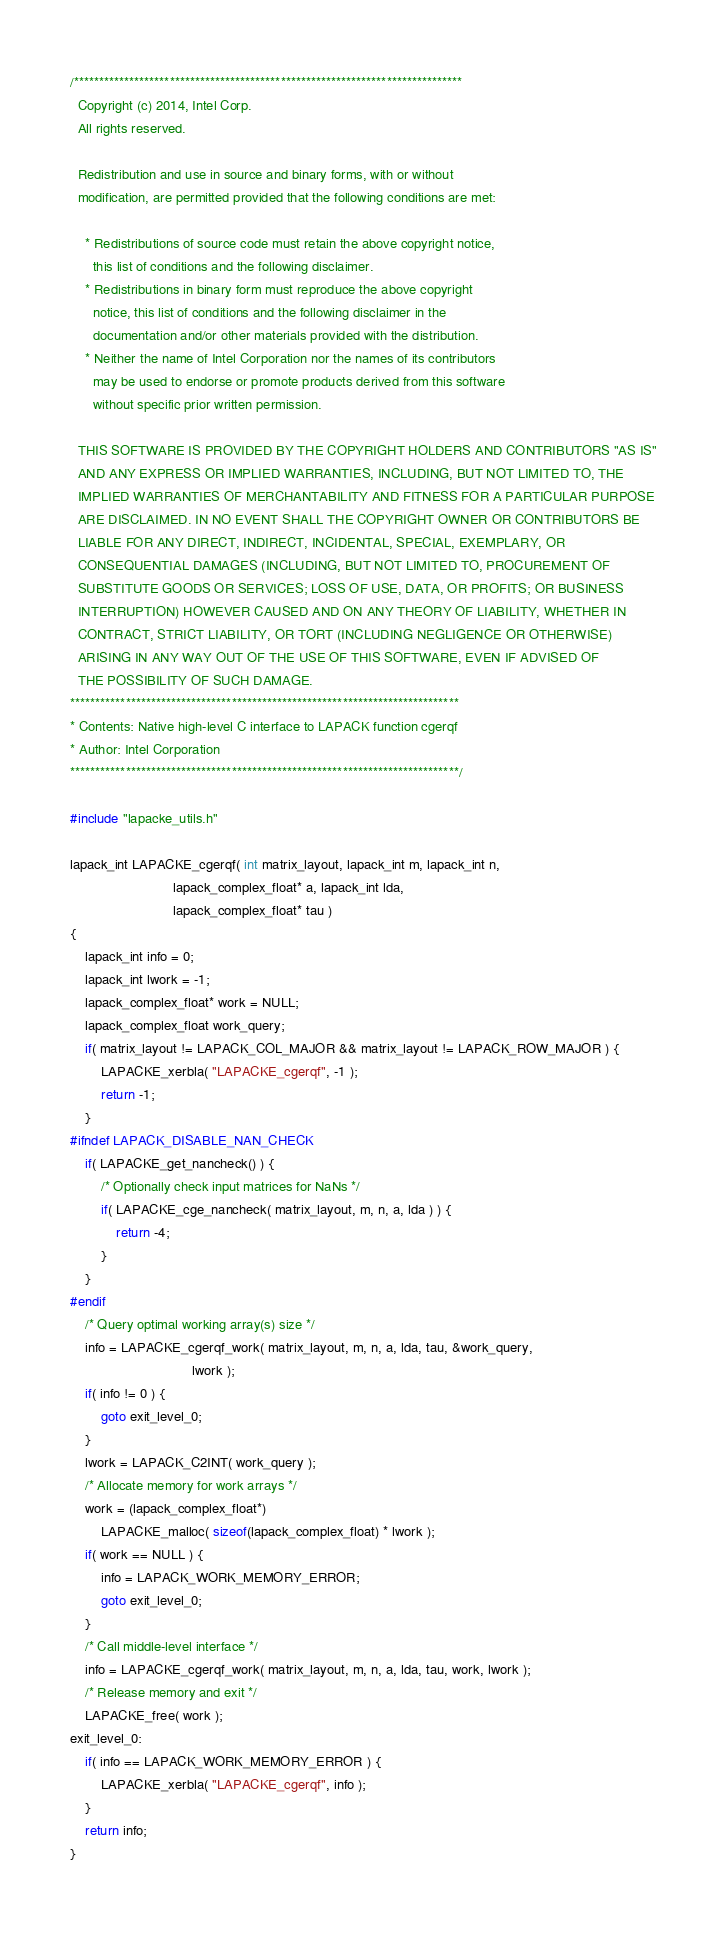<code> <loc_0><loc_0><loc_500><loc_500><_C_>/*****************************************************************************
  Copyright (c) 2014, Intel Corp.
  All rights reserved.

  Redistribution and use in source and binary forms, with or without
  modification, are permitted provided that the following conditions are met:

    * Redistributions of source code must retain the above copyright notice,
      this list of conditions and the following disclaimer.
    * Redistributions in binary form must reproduce the above copyright
      notice, this list of conditions and the following disclaimer in the
      documentation and/or other materials provided with the distribution.
    * Neither the name of Intel Corporation nor the names of its contributors
      may be used to endorse or promote products derived from this software
      without specific prior written permission.

  THIS SOFTWARE IS PROVIDED BY THE COPYRIGHT HOLDERS AND CONTRIBUTORS "AS IS"
  AND ANY EXPRESS OR IMPLIED WARRANTIES, INCLUDING, BUT NOT LIMITED TO, THE
  IMPLIED WARRANTIES OF MERCHANTABILITY AND FITNESS FOR A PARTICULAR PURPOSE
  ARE DISCLAIMED. IN NO EVENT SHALL THE COPYRIGHT OWNER OR CONTRIBUTORS BE
  LIABLE FOR ANY DIRECT, INDIRECT, INCIDENTAL, SPECIAL, EXEMPLARY, OR
  CONSEQUENTIAL DAMAGES (INCLUDING, BUT NOT LIMITED TO, PROCUREMENT OF
  SUBSTITUTE GOODS OR SERVICES; LOSS OF USE, DATA, OR PROFITS; OR BUSINESS
  INTERRUPTION) HOWEVER CAUSED AND ON ANY THEORY OF LIABILITY, WHETHER IN
  CONTRACT, STRICT LIABILITY, OR TORT (INCLUDING NEGLIGENCE OR OTHERWISE)
  ARISING IN ANY WAY OUT OF THE USE OF THIS SOFTWARE, EVEN IF ADVISED OF
  THE POSSIBILITY OF SUCH DAMAGE.
*****************************************************************************
* Contents: Native high-level C interface to LAPACK function cgerqf
* Author: Intel Corporation
*****************************************************************************/

#include "lapacke_utils.h"

lapack_int LAPACKE_cgerqf( int matrix_layout, lapack_int m, lapack_int n,
                           lapack_complex_float* a, lapack_int lda,
                           lapack_complex_float* tau )
{
    lapack_int info = 0;
    lapack_int lwork = -1;
    lapack_complex_float* work = NULL;
    lapack_complex_float work_query;
    if( matrix_layout != LAPACK_COL_MAJOR && matrix_layout != LAPACK_ROW_MAJOR ) {
        LAPACKE_xerbla( "LAPACKE_cgerqf", -1 );
        return -1;
    }
#ifndef LAPACK_DISABLE_NAN_CHECK
    if( LAPACKE_get_nancheck() ) {
        /* Optionally check input matrices for NaNs */
        if( LAPACKE_cge_nancheck( matrix_layout, m, n, a, lda ) ) {
            return -4;
        }
    }
#endif
    /* Query optimal working array(s) size */
    info = LAPACKE_cgerqf_work( matrix_layout, m, n, a, lda, tau, &work_query,
                                lwork );
    if( info != 0 ) {
        goto exit_level_0;
    }
    lwork = LAPACK_C2INT( work_query );
    /* Allocate memory for work arrays */
    work = (lapack_complex_float*)
        LAPACKE_malloc( sizeof(lapack_complex_float) * lwork );
    if( work == NULL ) {
        info = LAPACK_WORK_MEMORY_ERROR;
        goto exit_level_0;
    }
    /* Call middle-level interface */
    info = LAPACKE_cgerqf_work( matrix_layout, m, n, a, lda, tau, work, lwork );
    /* Release memory and exit */
    LAPACKE_free( work );
exit_level_0:
    if( info == LAPACK_WORK_MEMORY_ERROR ) {
        LAPACKE_xerbla( "LAPACKE_cgerqf", info );
    }
    return info;
}
</code> 